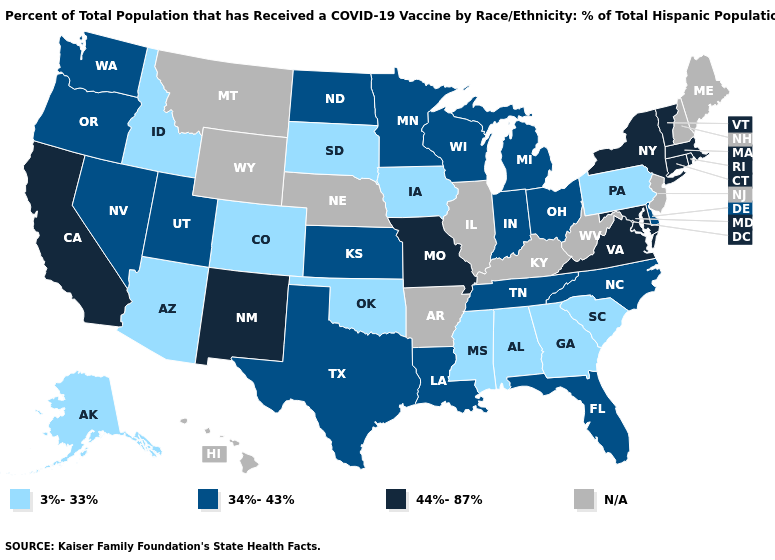Name the states that have a value in the range 3%-33%?
Keep it brief. Alabama, Alaska, Arizona, Colorado, Georgia, Idaho, Iowa, Mississippi, Oklahoma, Pennsylvania, South Carolina, South Dakota. Among the states that border Colorado , does Utah have the lowest value?
Quick response, please. No. Name the states that have a value in the range N/A?
Quick response, please. Arkansas, Hawaii, Illinois, Kentucky, Maine, Montana, Nebraska, New Hampshire, New Jersey, West Virginia, Wyoming. Does Pennsylvania have the highest value in the Northeast?
Concise answer only. No. Name the states that have a value in the range 3%-33%?
Keep it brief. Alabama, Alaska, Arizona, Colorado, Georgia, Idaho, Iowa, Mississippi, Oklahoma, Pennsylvania, South Carolina, South Dakota. What is the lowest value in states that border Idaho?
Write a very short answer. 34%-43%. What is the lowest value in the USA?
Answer briefly. 3%-33%. What is the value of Florida?
Quick response, please. 34%-43%. Name the states that have a value in the range 44%-87%?
Short answer required. California, Connecticut, Maryland, Massachusetts, Missouri, New Mexico, New York, Rhode Island, Vermont, Virginia. Which states have the highest value in the USA?
Write a very short answer. California, Connecticut, Maryland, Massachusetts, Missouri, New Mexico, New York, Rhode Island, Vermont, Virginia. What is the highest value in states that border California?
Write a very short answer. 34%-43%. Among the states that border Arizona , does New Mexico have the highest value?
Answer briefly. Yes. What is the value of Washington?
Be succinct. 34%-43%. What is the value of Illinois?
Be succinct. N/A. 